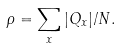Convert formula to latex. <formula><loc_0><loc_0><loc_500><loc_500>\rho = \sum _ { x } | Q _ { x } | / N .</formula> 